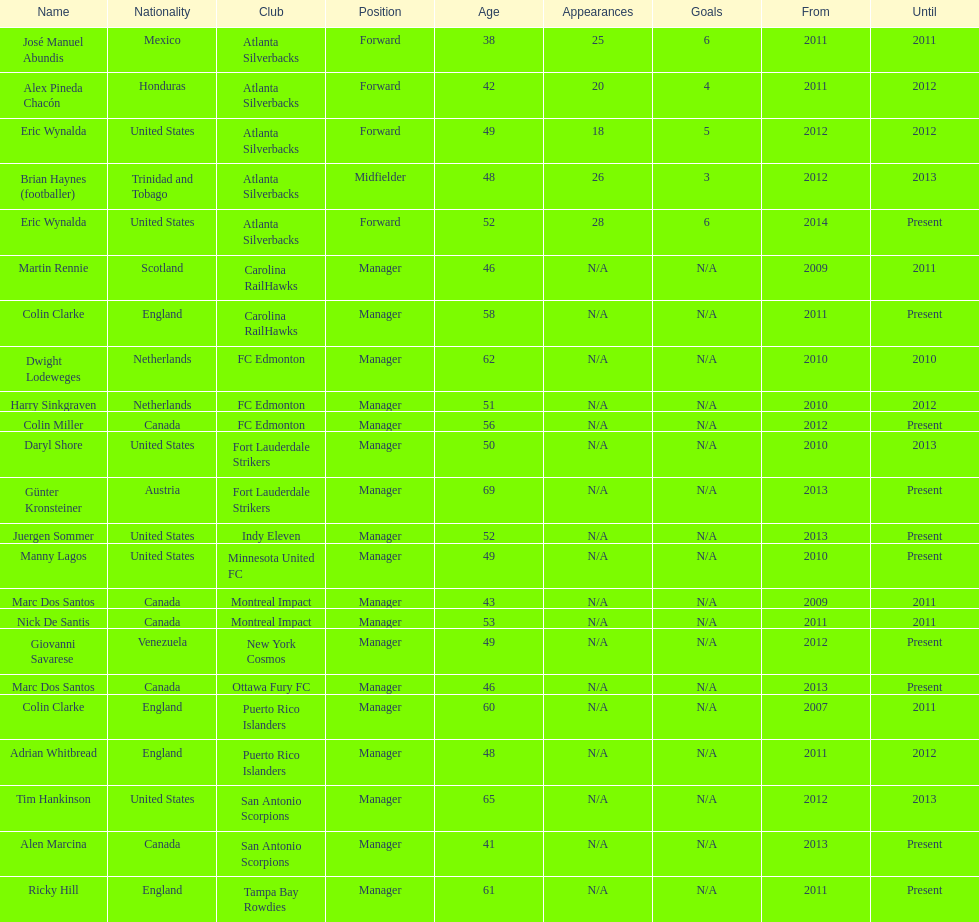Would you be able to parse every entry in this table? {'header': ['Name', 'Nationality', 'Club', 'Position', 'Age', 'Appearances', 'Goals', 'From', 'Until'], 'rows': [['José Manuel Abundis', 'Mexico', 'Atlanta Silverbacks', 'Forward', '38', '25', '6', '2011', '2011'], ['Alex Pineda Chacón', 'Honduras', 'Atlanta Silverbacks', 'Forward', '42', '20', '4', '2011', '2012'], ['Eric Wynalda', 'United States', 'Atlanta Silverbacks', 'Forward', '49', '18', '5', '2012', '2012'], ['Brian Haynes (footballer)', 'Trinidad and Tobago', 'Atlanta Silverbacks', 'Midfielder', '48', '26', '3', '2012', '2013'], ['Eric Wynalda', 'United States', 'Atlanta Silverbacks', 'Forward', '52', '28', '6', '2014', 'Present'], ['Martin Rennie', 'Scotland', 'Carolina RailHawks', 'Manager', '46', 'N/A', 'N/A', '2009', '2011'], ['Colin Clarke', 'England', 'Carolina RailHawks', 'Manager', '58', 'N/A', 'N/A', '2011', 'Present'], ['Dwight Lodeweges', 'Netherlands', 'FC Edmonton', 'Manager', '62', 'N/A', 'N/A', '2010', '2010'], ['Harry Sinkgraven', 'Netherlands', 'FC Edmonton', 'Manager', '51', 'N/A', 'N/A', '2010', '2012'], ['Colin Miller', 'Canada', 'FC Edmonton', 'Manager', '56', 'N/A', 'N/A', '2012', 'Present'], ['Daryl Shore', 'United States', 'Fort Lauderdale Strikers', 'Manager', '50', 'N/A', 'N/A', '2010', '2013'], ['Günter Kronsteiner', 'Austria', 'Fort Lauderdale Strikers', 'Manager', '69', 'N/A', 'N/A', '2013', 'Present'], ['Juergen Sommer', 'United States', 'Indy Eleven', 'Manager', '52', 'N/A', 'N/A', '2013', 'Present'], ['Manny Lagos', 'United States', 'Minnesota United FC', 'Manager', '49', 'N/A', 'N/A', '2010', 'Present'], ['Marc Dos Santos', 'Canada', 'Montreal Impact', 'Manager', '43', 'N/A', 'N/A', '2009', '2011'], ['Nick De Santis', 'Canada', 'Montreal Impact', 'Manager', '53', 'N/A', 'N/A', '2011', '2011'], ['Giovanni Savarese', 'Venezuela', 'New York Cosmos', 'Manager', '49', 'N/A', 'N/A', '2012', 'Present'], ['Marc Dos Santos', 'Canada', 'Ottawa Fury FC', 'Manager', '46', 'N/A', 'N/A', '2013', 'Present'], ['Colin Clarke', 'England', 'Puerto Rico Islanders', 'Manager', '60', 'N/A', 'N/A', '2007', '2011'], ['Adrian Whitbread', 'England', 'Puerto Rico Islanders', 'Manager', '48', 'N/A', 'N/A', '2011', '2012'], ['Tim Hankinson', 'United States', 'San Antonio Scorpions', 'Manager', '65', 'N/A', 'N/A', '2012', '2013'], ['Alen Marcina', 'Canada', 'San Antonio Scorpions', 'Manager', '41', 'N/A', 'N/A', '2013', 'Present'], ['Ricky Hill', 'England', 'Tampa Bay Rowdies', 'Manager', '61', 'N/A', 'N/A', '2011', 'Present']]} Who is the last to coach the san antonio scorpions? Alen Marcina. 